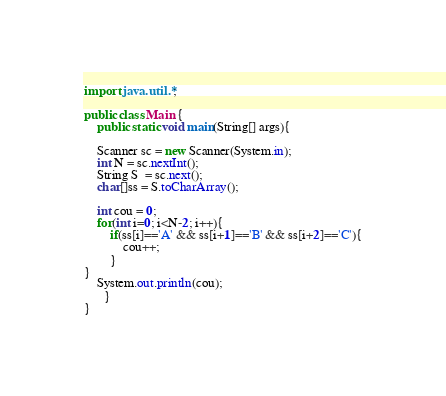<code> <loc_0><loc_0><loc_500><loc_500><_Java_>import java.util.*;

public class Main {
    public static void main(String[] args){
    
    Scanner sc = new Scanner(System.in);
    int N = sc.nextInt();
    String S  = sc.next();
    char[]ss = S.toCharArray();
    
    int cou = 0;
    for(int i=0; i<N-2; i++){
        if(ss[i]=='A' && ss[i+1]=='B' && ss[i+2]=='C'){
            cou++;
        }   
}
	System.out.println(cou);
      }
}</code> 